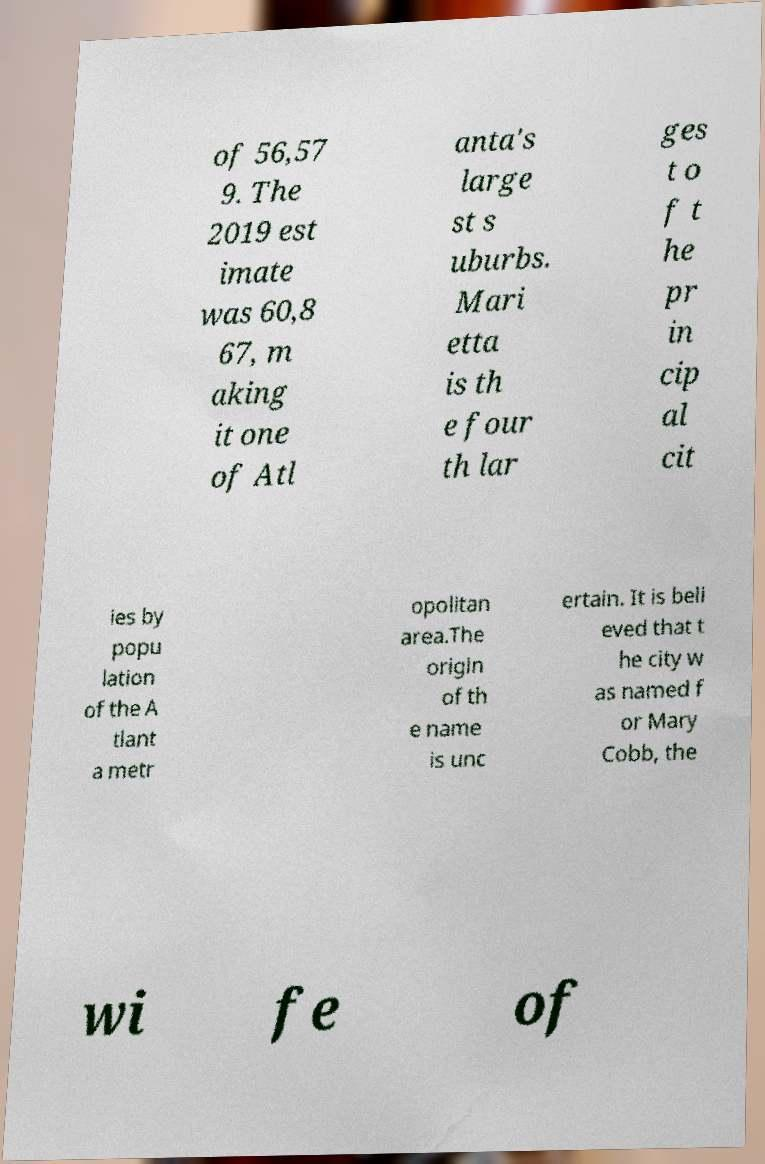For documentation purposes, I need the text within this image transcribed. Could you provide that? of 56,57 9. The 2019 est imate was 60,8 67, m aking it one of Atl anta's large st s uburbs. Mari etta is th e four th lar ges t o f t he pr in cip al cit ies by popu lation of the A tlant a metr opolitan area.The origin of th e name is unc ertain. It is beli eved that t he city w as named f or Mary Cobb, the wi fe of 